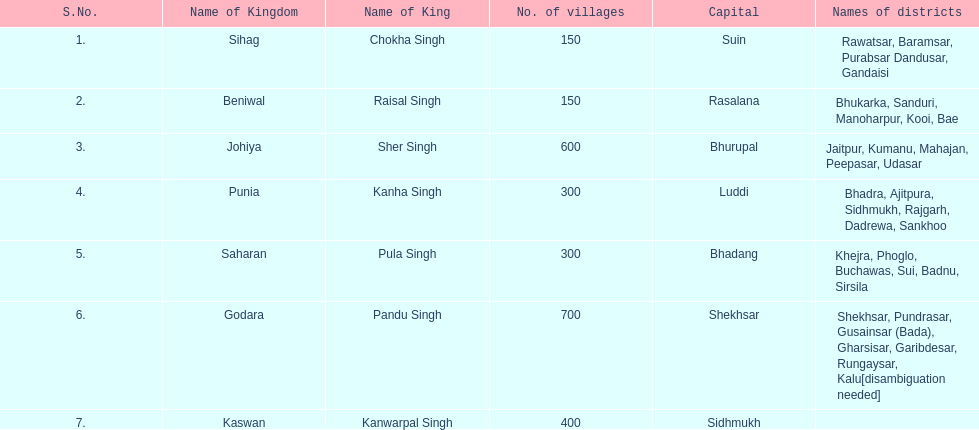Give me the full table as a dictionary. {'header': ['S.No.', 'Name of Kingdom', 'Name of King', 'No. of villages', 'Capital', 'Names of districts'], 'rows': [['1.', 'Sihag', 'Chokha Singh', '150', 'Suin', 'Rawatsar, Baramsar, Purabsar Dandusar, Gandaisi'], ['2.', 'Beniwal', 'Raisal Singh', '150', 'Rasalana', 'Bhukarka, Sanduri, Manoharpur, Kooi, Bae'], ['3.', 'Johiya', 'Sher Singh', '600', 'Bhurupal', 'Jaitpur, Kumanu, Mahajan, Peepasar, Udasar'], ['4.', 'Punia', 'Kanha Singh', '300', 'Luddi', 'Bhadra, Ajitpura, Sidhmukh, Rajgarh, Dadrewa, Sankhoo'], ['5.', 'Saharan', 'Pula Singh', '300', 'Bhadang', 'Khejra, Phoglo, Buchawas, Sui, Badnu, Sirsila'], ['6.', 'Godara', 'Pandu Singh', '700', 'Shekhsar', 'Shekhsar, Pundrasar, Gusainsar (Bada), Gharsisar, Garibdesar, Rungaysar, Kalu[disambiguation needed]'], ['7.', 'Kaswan', 'Kanwarpal Singh', '400', 'Sidhmukh', '']]} Can you identify the monarch of the sihag kingdom? Chokha Singh. 